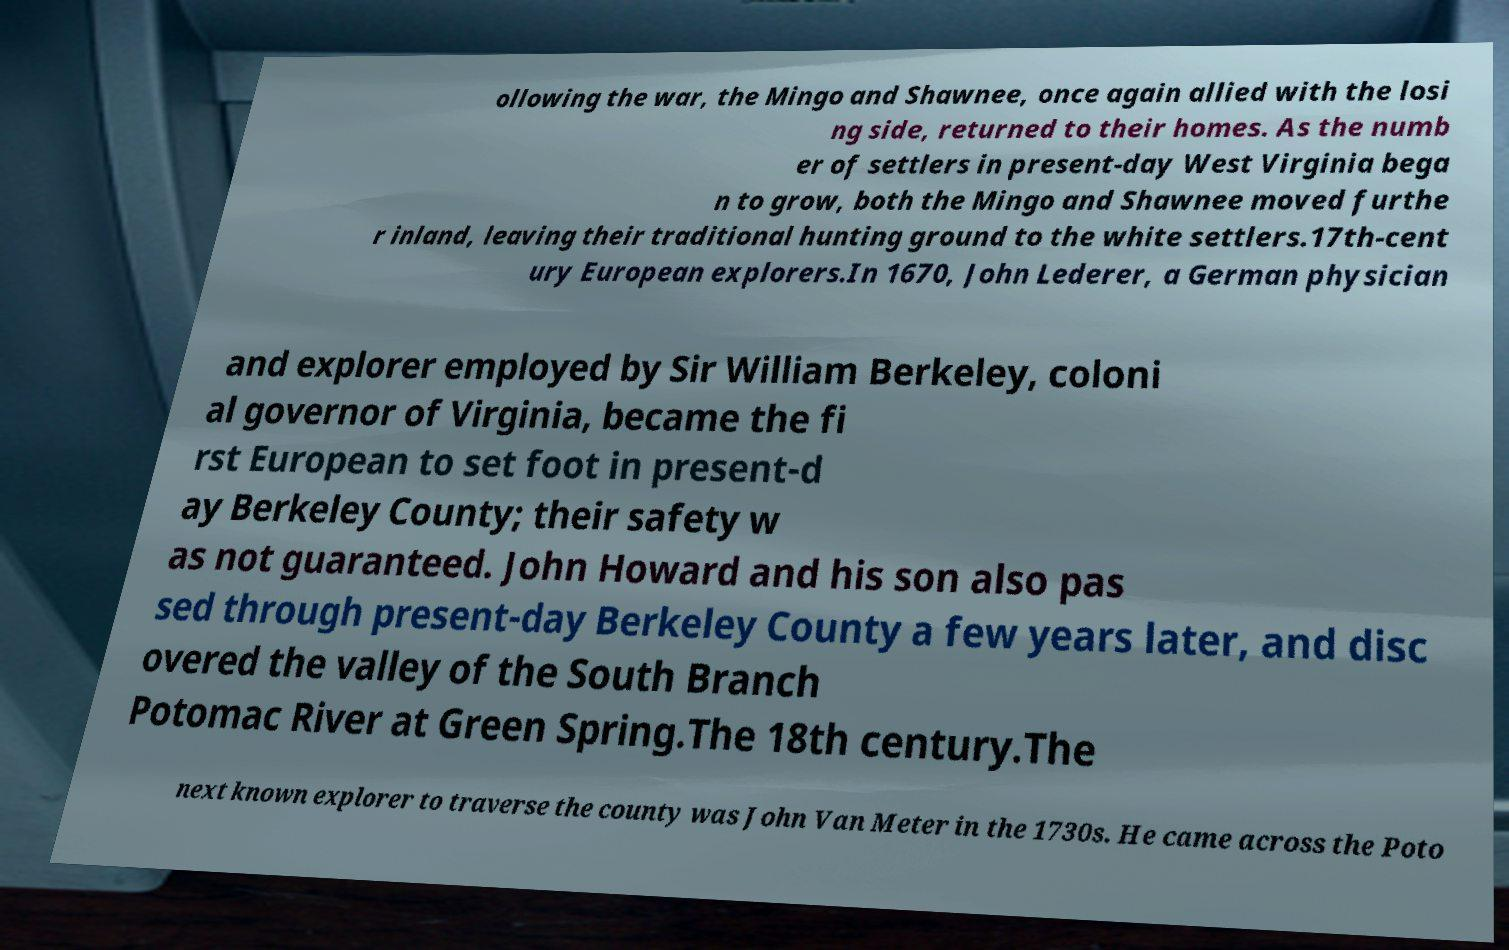For documentation purposes, I need the text within this image transcribed. Could you provide that? ollowing the war, the Mingo and Shawnee, once again allied with the losi ng side, returned to their homes. As the numb er of settlers in present-day West Virginia bega n to grow, both the Mingo and Shawnee moved furthe r inland, leaving their traditional hunting ground to the white settlers.17th-cent ury European explorers.In 1670, John Lederer, a German physician and explorer employed by Sir William Berkeley, coloni al governor of Virginia, became the fi rst European to set foot in present-d ay Berkeley County; their safety w as not guaranteed. John Howard and his son also pas sed through present-day Berkeley County a few years later, and disc overed the valley of the South Branch Potomac River at Green Spring.The 18th century.The next known explorer to traverse the county was John Van Meter in the 1730s. He came across the Poto 